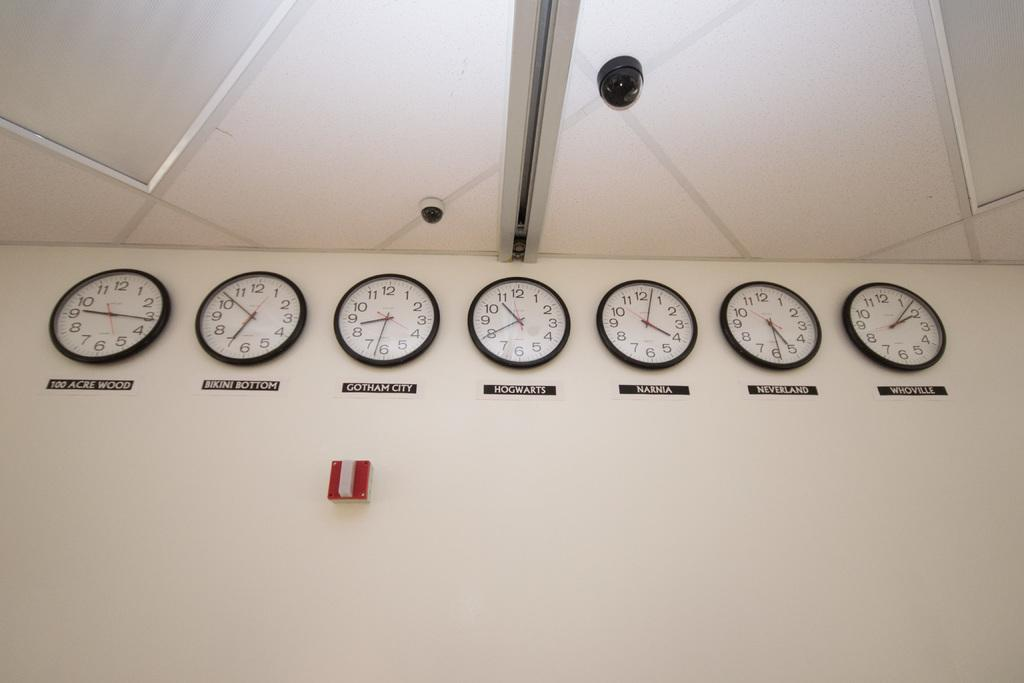<image>
Offer a succinct explanation of the picture presented. A series of clocks on the wall showing the times in various places, like Narnia, Gotham City, and Whoville. 